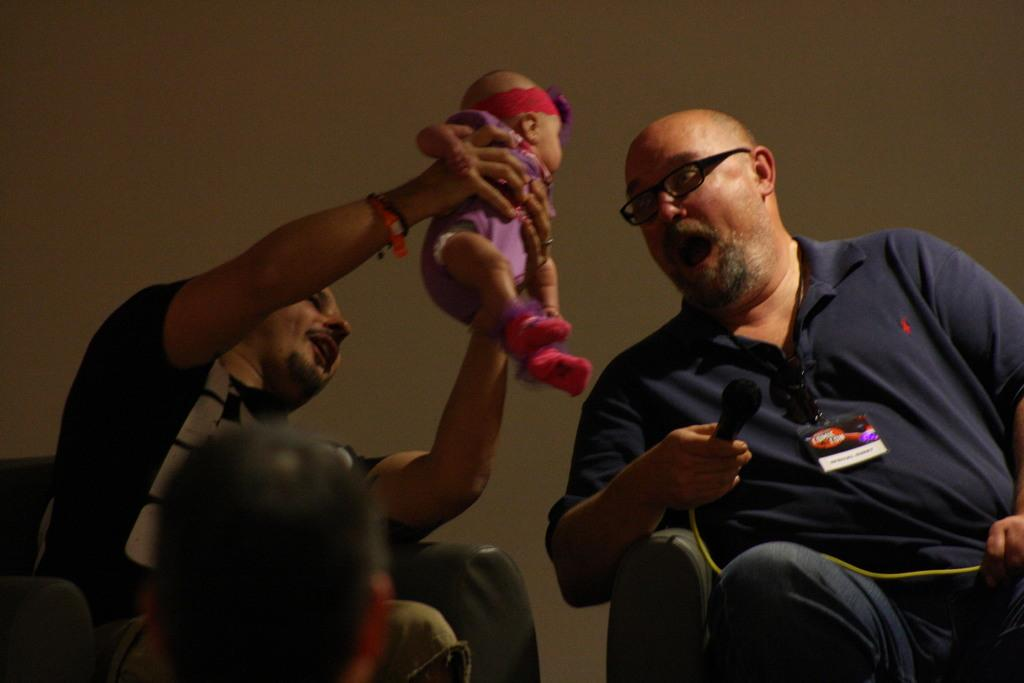How many people are sitting in the chair in the image? There are two people sitting in the chair in the image. What is one person doing while sitting in the chair? One person is holding an infant. What can be seen in the background of the image? There is a wall in the background of the image. What nation is being represented by the flag in the image? There is no flag present in the image. How many drops of water are visible on the infant's face in the image? There is no water visible on the infant's face in the image. 